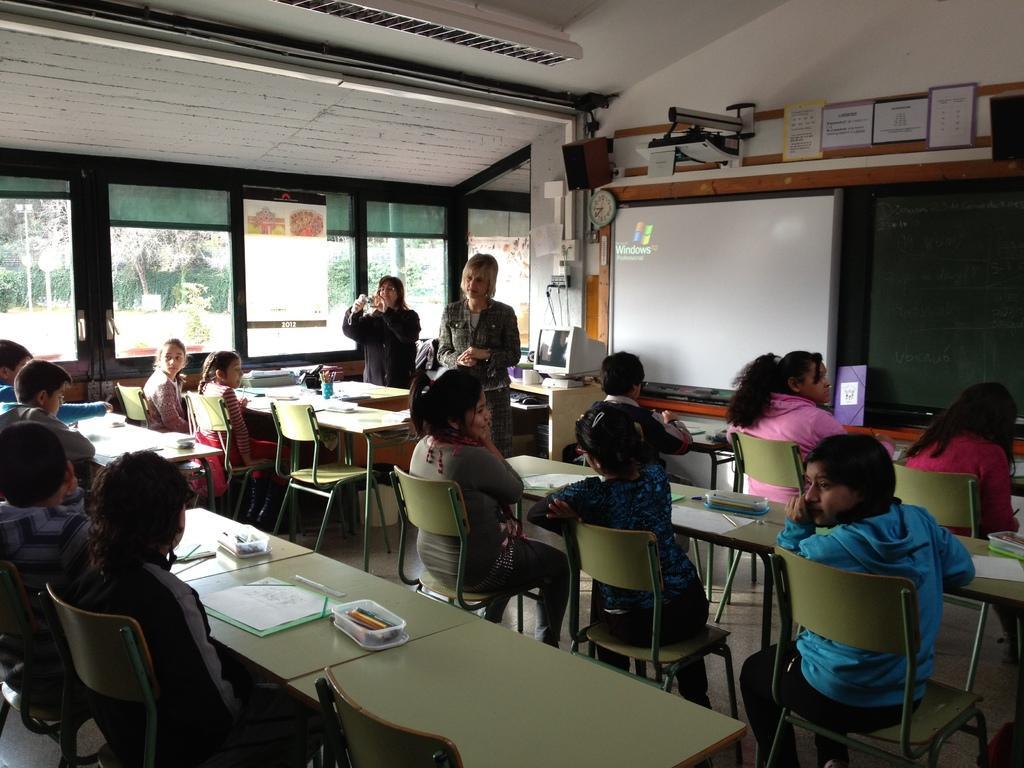Please provide a concise description of this image. In this picture we can see some persons are sitting on the chairs. This is the table. On the table there is a box, book, a measuring scale. And these are the windows, from the windows we can see some trees. On the background we can see a screen. And this is the board. Even we can see two persons are standing here. And this is the wall. 